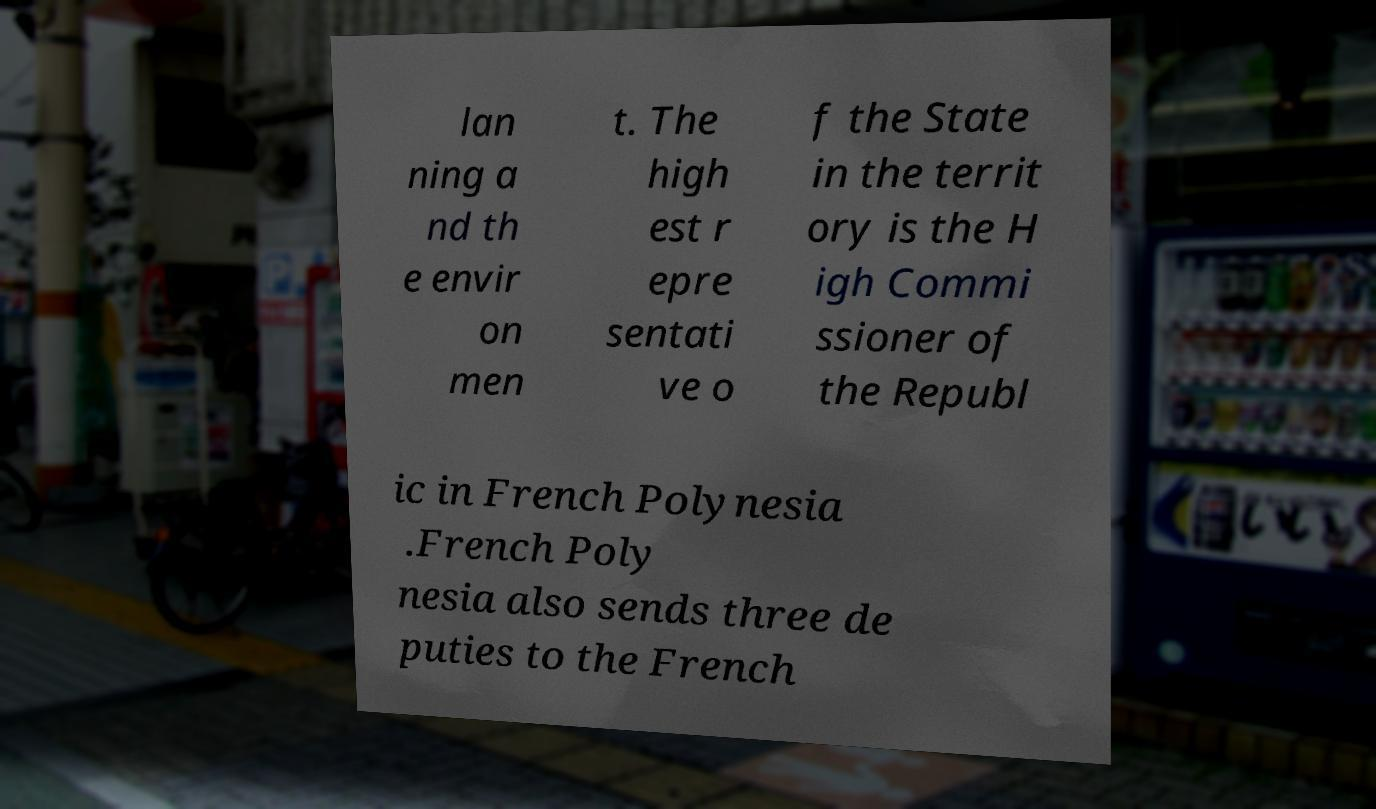Could you extract and type out the text from this image? lan ning a nd th e envir on men t. The high est r epre sentati ve o f the State in the territ ory is the H igh Commi ssioner of the Republ ic in French Polynesia .French Poly nesia also sends three de puties to the French 